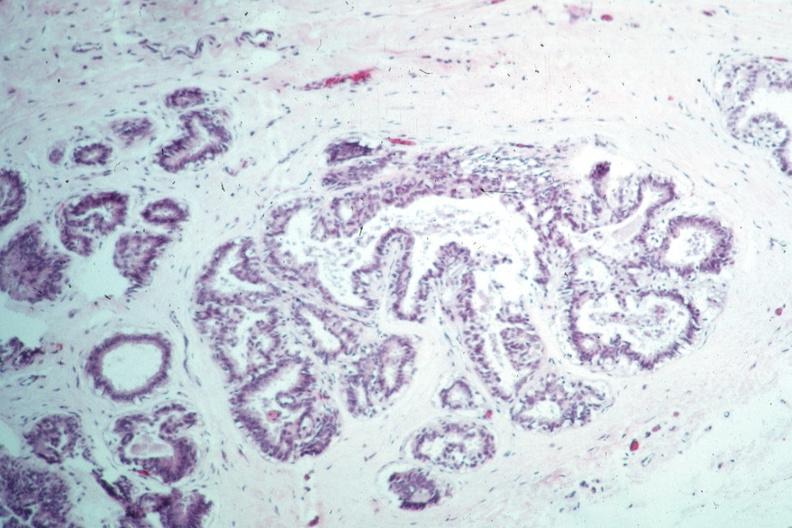where is this area in the body?
Answer the question using a single word or phrase. Breast 